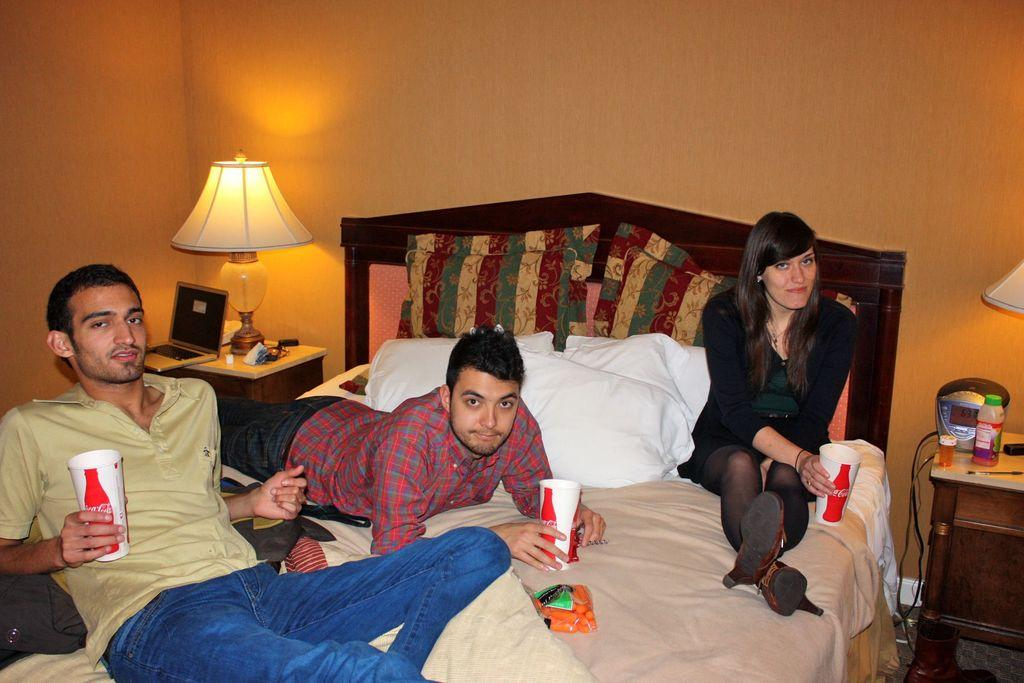How many people are on the bed in the image? There are three persons on the bed in the image. What can be found on the bed besides the people? There are pillows on the bed. What is one person holding in the image? One person is holding a glass. What can be seen in the background of the image? There is a wall and a lamp in the background. What electronic device is present in the image? There is a laptop in the image. Are there any tigers or dogs visible in the image? No, there are no tigers or dogs present in the image. Is there an army of ants marching across the laptop screen in the image? No, there is no army of ants or any other insects visible on the laptop screen in the image. 